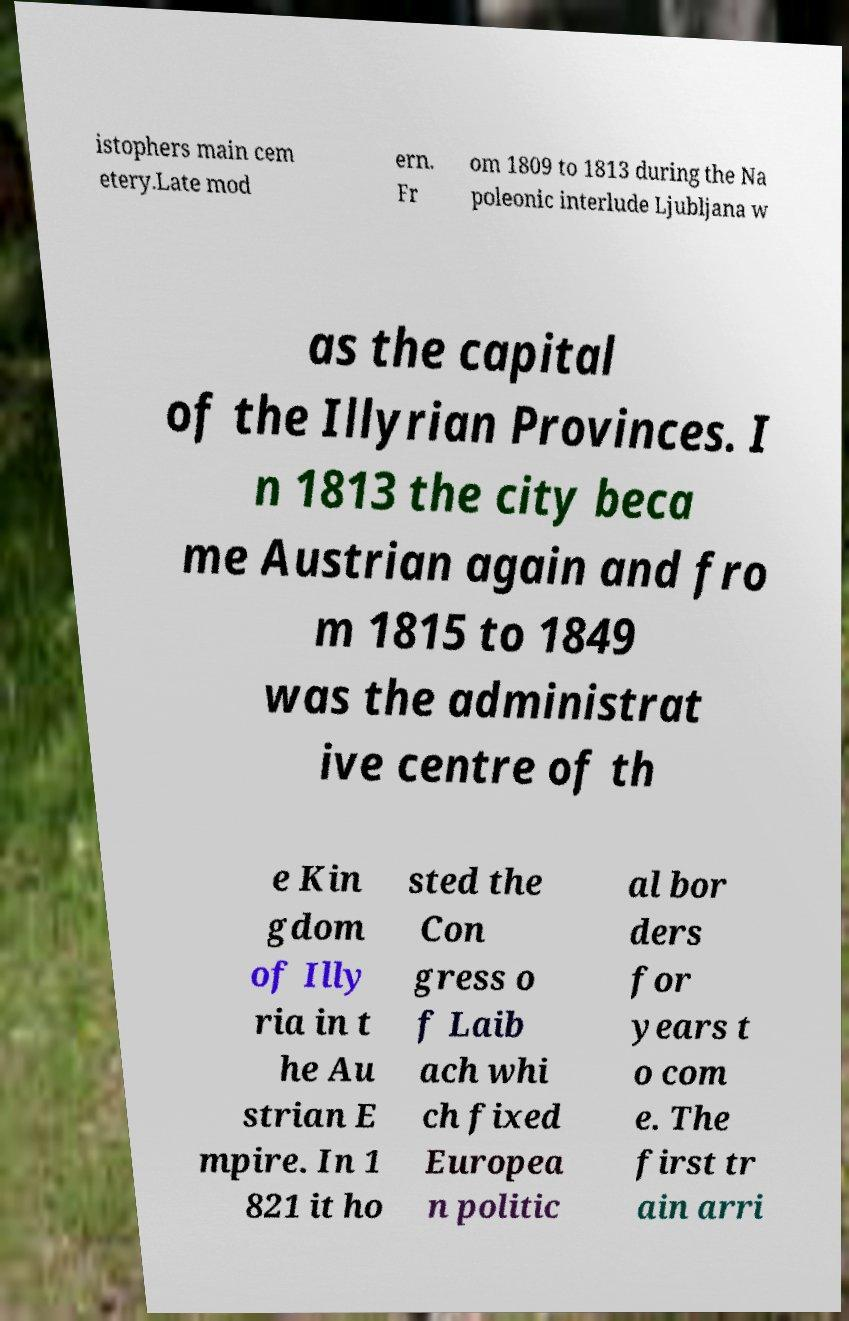Please read and relay the text visible in this image. What does it say? istophers main cem etery.Late mod ern. Fr om 1809 to 1813 during the Na poleonic interlude Ljubljana w as the capital of the Illyrian Provinces. I n 1813 the city beca me Austrian again and fro m 1815 to 1849 was the administrat ive centre of th e Kin gdom of Illy ria in t he Au strian E mpire. In 1 821 it ho sted the Con gress o f Laib ach whi ch fixed Europea n politic al bor ders for years t o com e. The first tr ain arri 